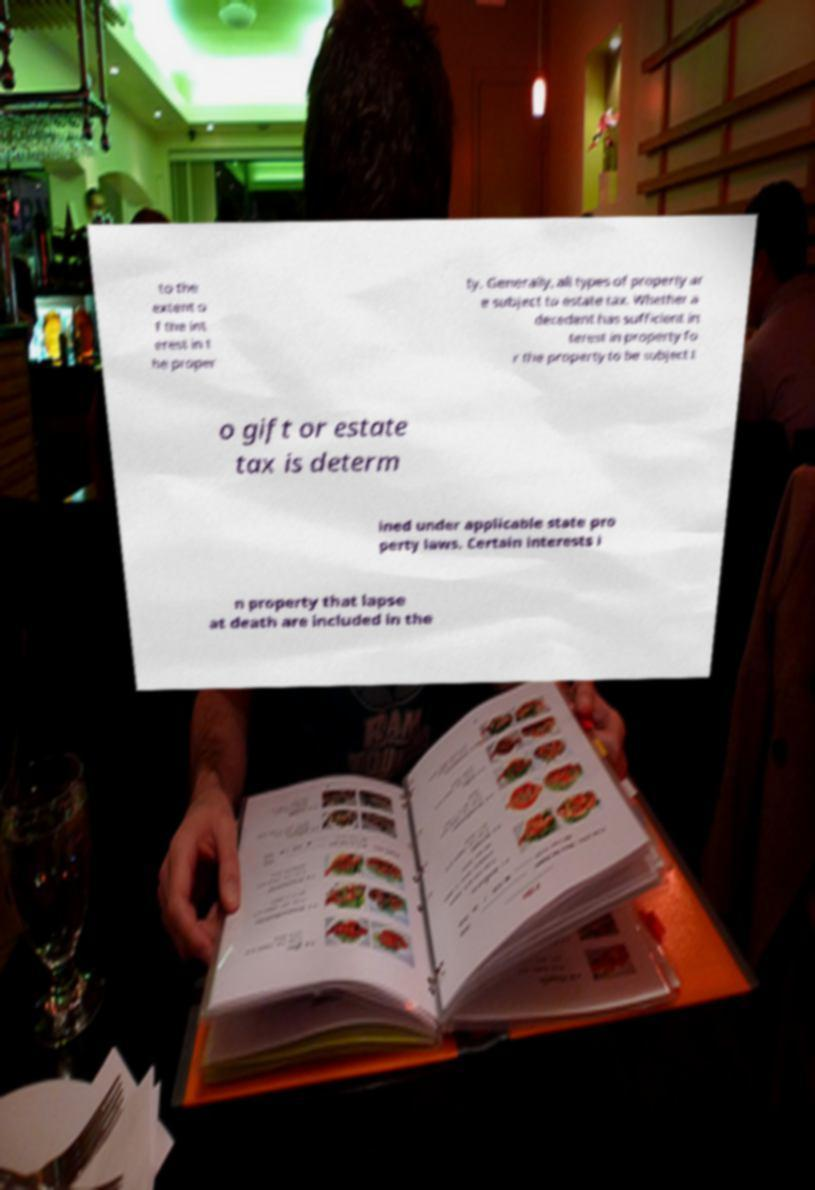Could you extract and type out the text from this image? to the extent o f the int erest in t he proper ty. Generally, all types of property ar e subject to estate tax. Whether a decedent has sufficient in terest in property fo r the property to be subject t o gift or estate tax is determ ined under applicable state pro perty laws. Certain interests i n property that lapse at death are included in the 